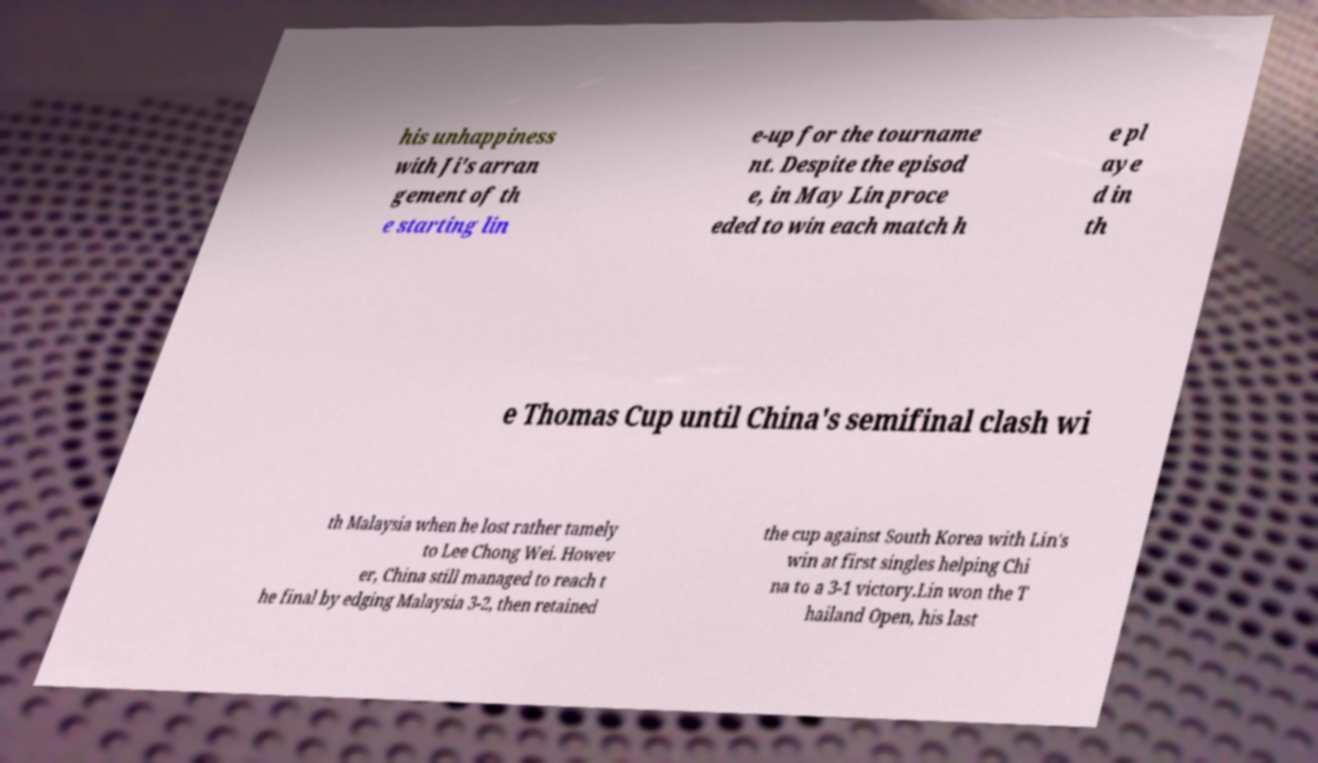Please read and relay the text visible in this image. What does it say? his unhappiness with Ji's arran gement of th e starting lin e-up for the tourname nt. Despite the episod e, in May Lin proce eded to win each match h e pl aye d in th e Thomas Cup until China's semifinal clash wi th Malaysia when he lost rather tamely to Lee Chong Wei. Howev er, China still managed to reach t he final by edging Malaysia 3-2, then retained the cup against South Korea with Lin's win at first singles helping Chi na to a 3-1 victory.Lin won the T hailand Open, his last 